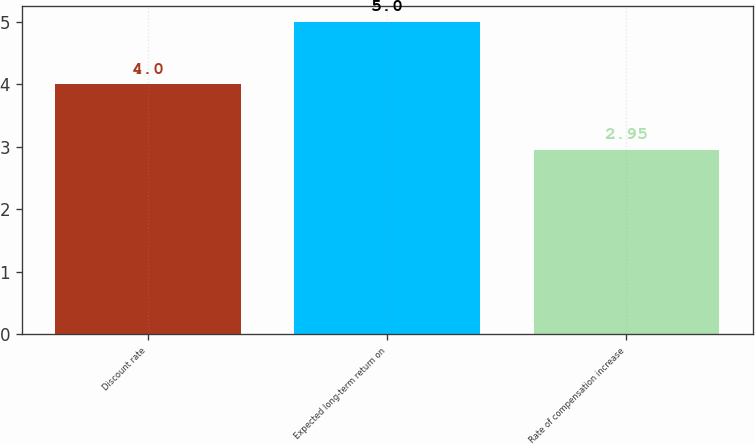Convert chart. <chart><loc_0><loc_0><loc_500><loc_500><bar_chart><fcel>Discount rate<fcel>Expected long-term return on<fcel>Rate of compensation increase<nl><fcel>4<fcel>5<fcel>2.95<nl></chart> 